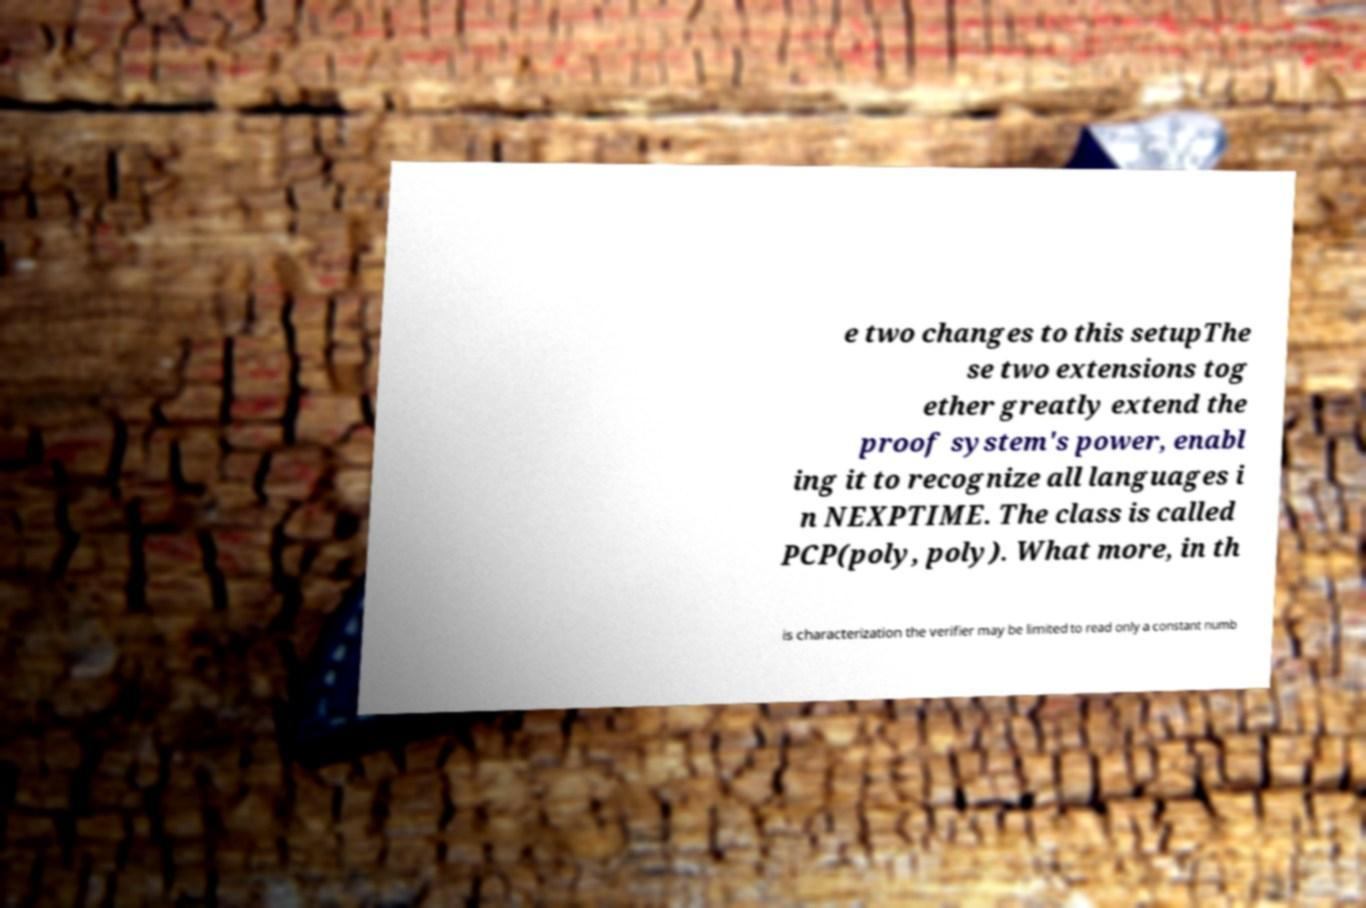What messages or text are displayed in this image? I need them in a readable, typed format. e two changes to this setupThe se two extensions tog ether greatly extend the proof system's power, enabl ing it to recognize all languages i n NEXPTIME. The class is called PCP(poly, poly). What more, in th is characterization the verifier may be limited to read only a constant numb 